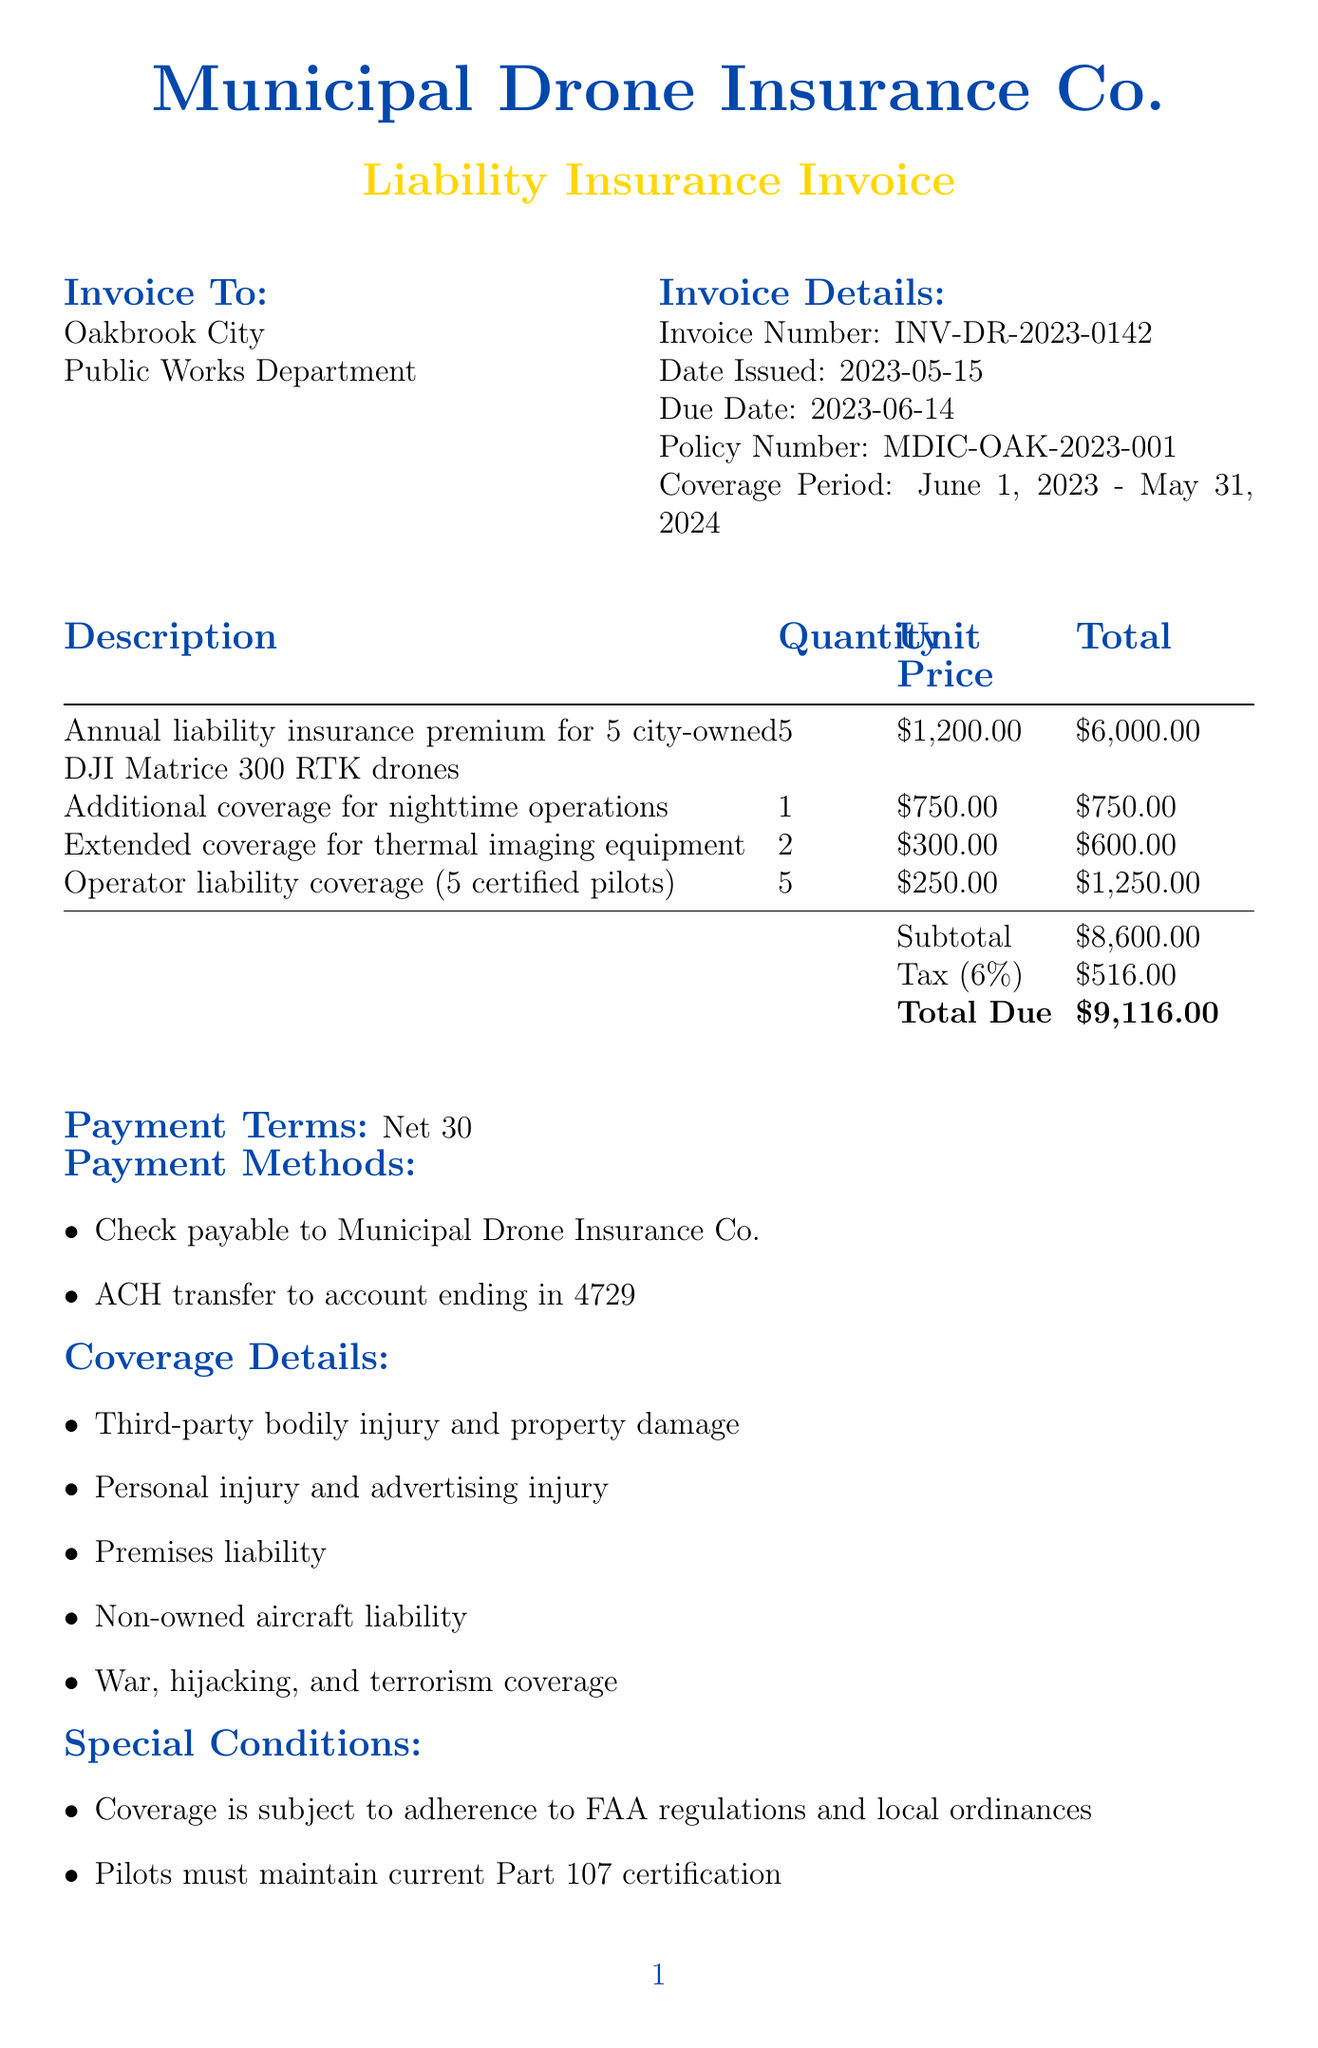What is the invoice number? The invoice number is explicitly stated in the document as part of the invoice details.
Answer: INV-DR-2023-0142 What is the total due amount? The total due amount is presented at the end of the line items section.
Answer: $9,116.00 Who is the insurance provider? The insurance provider's name is located at the top of the invoice.
Answer: Municipal Drone Insurance Co How many drones are covered under the policy? The number of drones is mentioned in the description of the annual liability insurance premium.
Answer: 5 What is the coverage period? The coverage period is specified in the invoice details section.
Answer: June 1, 2023 - May 31, 2024 What is the tax amount listed in the invoice? The tax amount is calculated and displayed alongside the subtotal.
Answer: $516.00 What is a special condition regarding the pilots? One of the special conditions states specific requirements for the pilots.
Answer: Pilots must maintain current Part 107 certification What payment methods are accepted? The document provides two options for payment methods below the payment terms.
Answer: Check payable to Municipal Drone Insurance Co., ACH transfer to account ending in 4729 Which department is responsible for the invoice? The responsible department is listed next to the city name in the invoice.
Answer: Public Works Department 